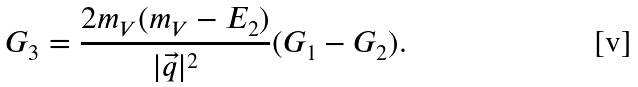<formula> <loc_0><loc_0><loc_500><loc_500>G _ { 3 } = \frac { 2 m _ { V } ( m _ { V } - E _ { 2 } ) } { | \vec { q } | ^ { 2 } } ( G _ { 1 } - G _ { 2 } ) .</formula> 